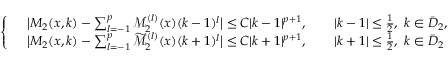Convert formula to latex. <formula><loc_0><loc_0><loc_500><loc_500>\begin{array} { r } { \left \{ \begin{array} { l l } & { \left | M _ { 2 } ( x , k ) - \sum _ { l = - 1 } ^ { p } \mathcal { M } _ { 2 } ^ { ( l ) } ( x ) ( k - 1 ) ^ { l } \right | \leq C | k - 1 | ^ { p + 1 } , \quad | k - 1 | \leq \frac { 1 } { 2 } , \ k \in \bar { D } _ { 2 } , } \\ & { \left | M _ { 2 } ( x , k ) - \sum _ { l = - 1 } ^ { p } \widetilde { \mathcal { M } } _ { 2 } ^ { ( l ) } ( x ) ( k + 1 ) ^ { l } \right | \leq C | k + 1 | ^ { p + 1 } , \quad | k + 1 | \leq \frac { 1 } { 2 } , \ k \in \bar { D } _ { 2 } } \end{array} } \end{array}</formula> 